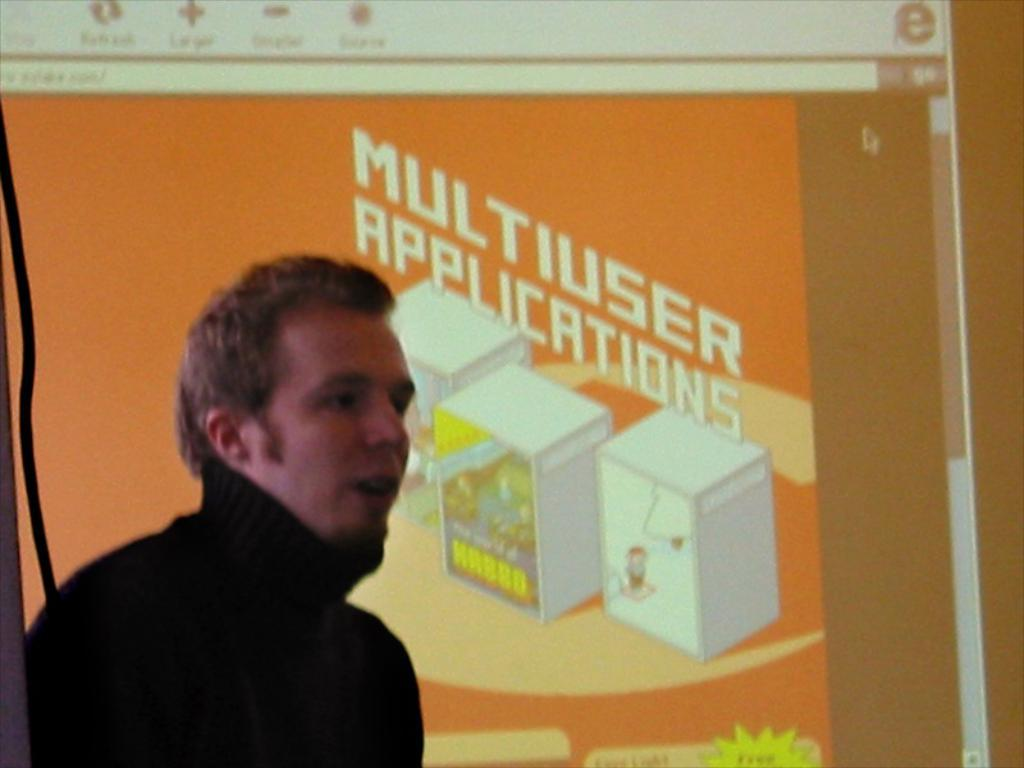Who is present in the image? There is a person in the image. What is the person wearing? The person is wearing a black dress. Where is the person located in the image? The person is in the left corner of the image. What can be seen in the background of the image? There is a projected image in the background of the image. What type of debt is the person discussing in the image? There is no indication in the image that the person is discussing debt, as the focus is on their clothing and location. 